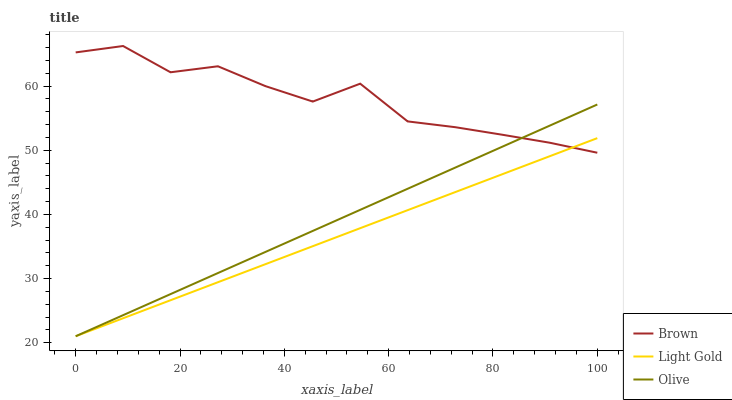Does Light Gold have the minimum area under the curve?
Answer yes or no. Yes. Does Brown have the maximum area under the curve?
Answer yes or no. Yes. Does Brown have the minimum area under the curve?
Answer yes or no. No. Does Light Gold have the maximum area under the curve?
Answer yes or no. No. Is Light Gold the smoothest?
Answer yes or no. Yes. Is Brown the roughest?
Answer yes or no. Yes. Is Brown the smoothest?
Answer yes or no. No. Is Light Gold the roughest?
Answer yes or no. No. Does Olive have the lowest value?
Answer yes or no. Yes. Does Brown have the lowest value?
Answer yes or no. No. Does Brown have the highest value?
Answer yes or no. Yes. Does Light Gold have the highest value?
Answer yes or no. No. Does Olive intersect Brown?
Answer yes or no. Yes. Is Olive less than Brown?
Answer yes or no. No. Is Olive greater than Brown?
Answer yes or no. No. 